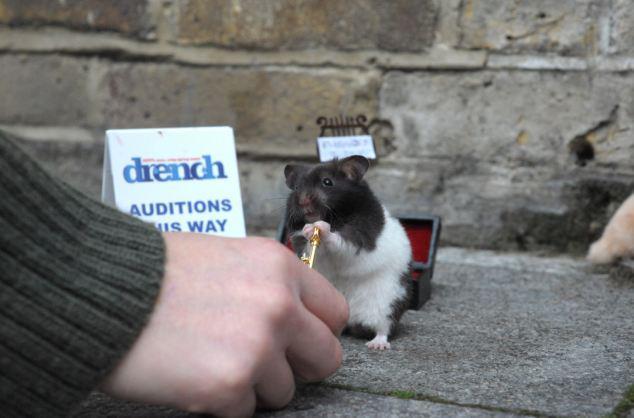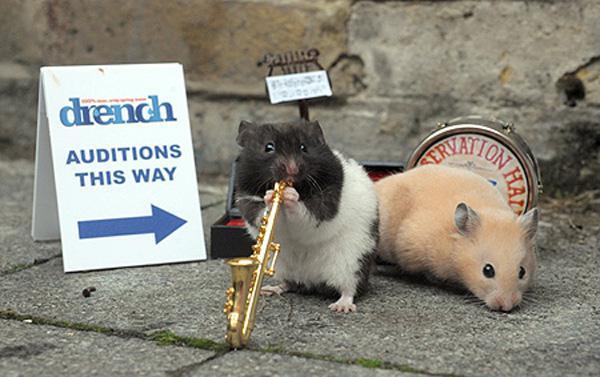The first image is the image on the left, the second image is the image on the right. For the images shown, is this caption "In at least one of the images there is a rodent playing an instrument" true? Answer yes or no. Yes. The first image is the image on the left, the second image is the image on the right. For the images displayed, is the sentence "There is at least one hamster playing a miniature saxophone." factually correct? Answer yes or no. Yes. 